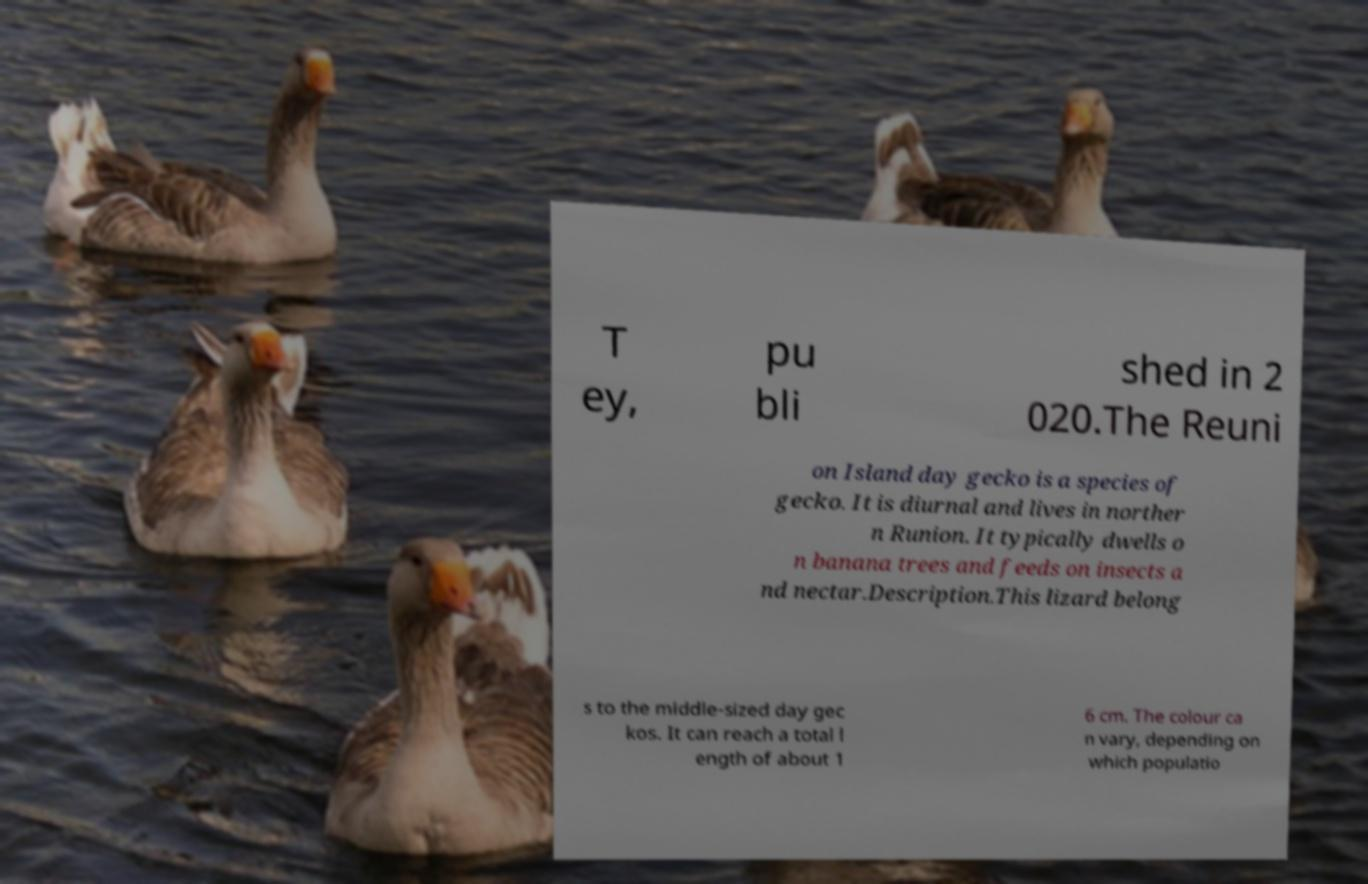Please identify and transcribe the text found in this image. T ey, pu bli shed in 2 020.The Reuni on Island day gecko is a species of gecko. It is diurnal and lives in norther n Runion. It typically dwells o n banana trees and feeds on insects a nd nectar.Description.This lizard belong s to the middle-sized day gec kos. It can reach a total l ength of about 1 6 cm. The colour ca n vary, depending on which populatio 